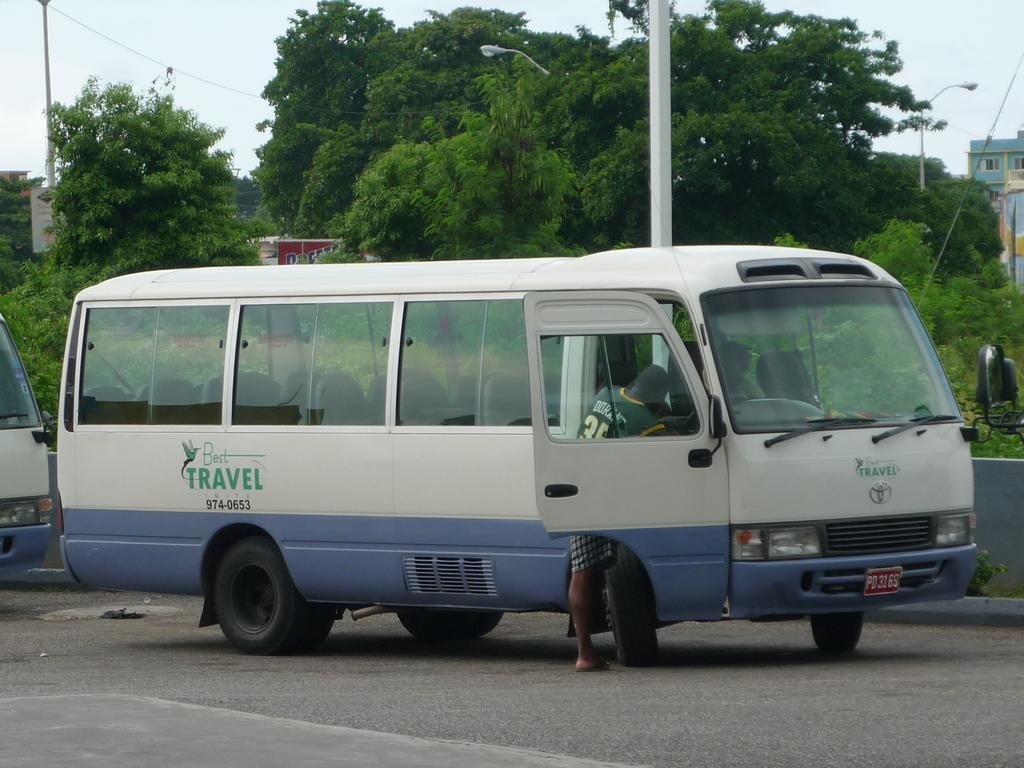<image>
Summarize the visual content of the image. a white and blue bus from Best Travel sits by the road 